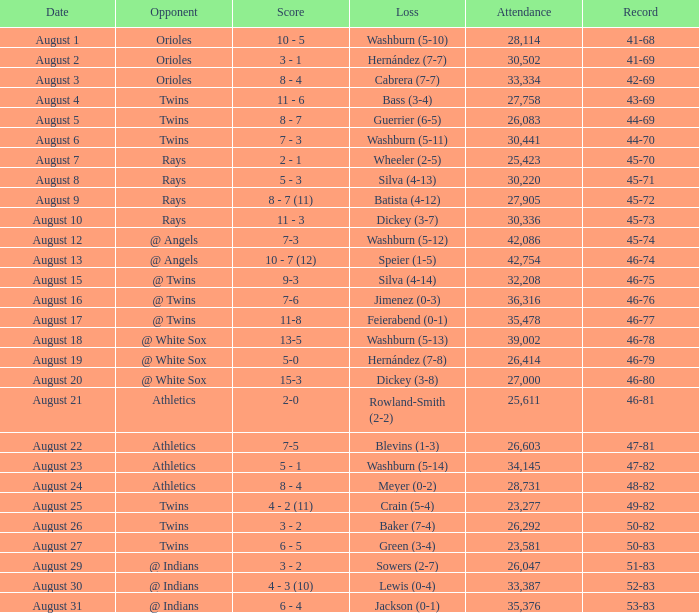What was the total loss on august 19th? Hernández (7-8). 